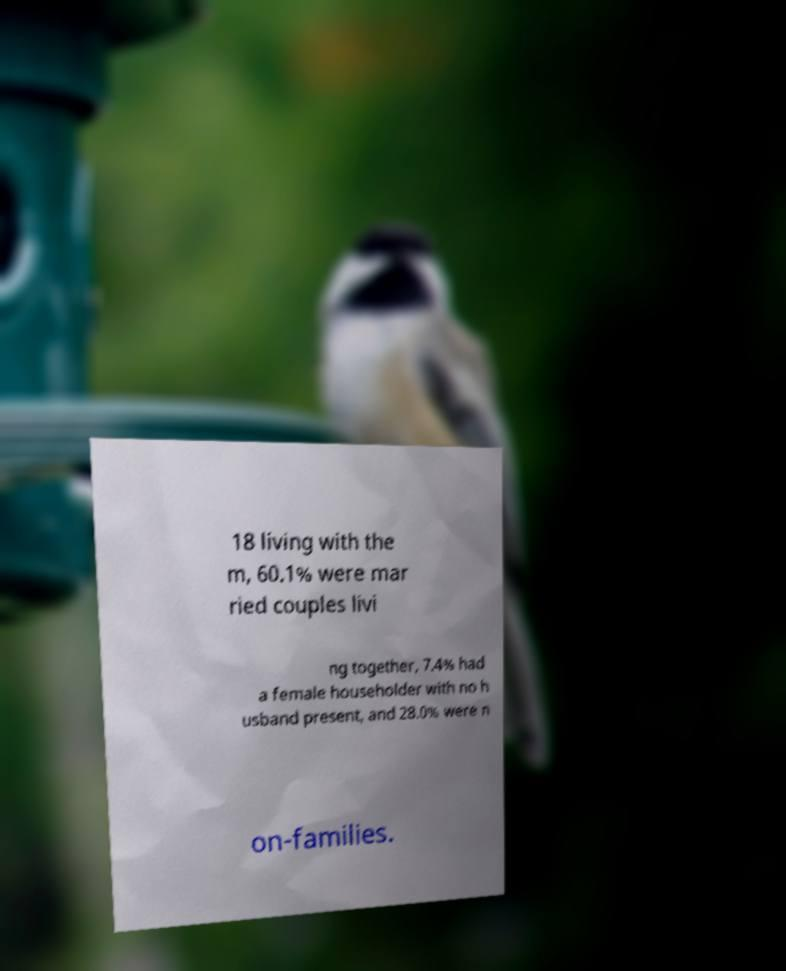Can you accurately transcribe the text from the provided image for me? 18 living with the m, 60.1% were mar ried couples livi ng together, 7.4% had a female householder with no h usband present, and 28.0% were n on-families. 